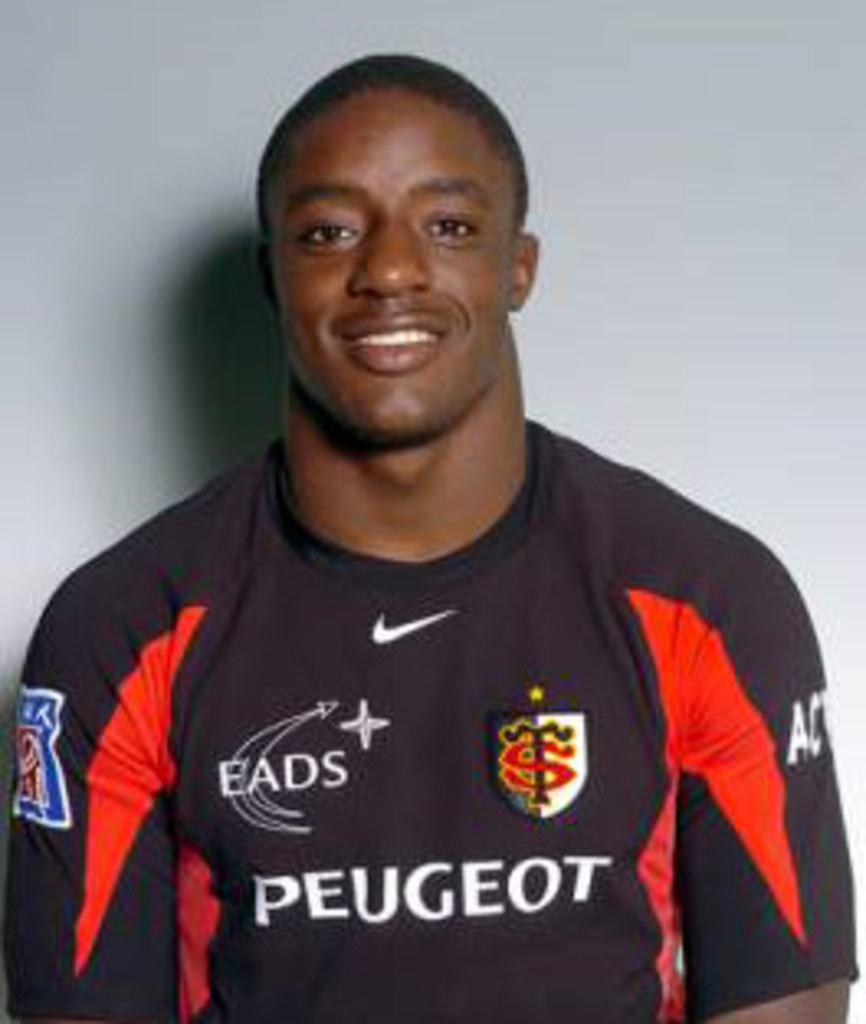Provide a one-sentence caption for the provided image. A man wearing a Peugeot jersey smiles for his picture. 